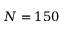<formula> <loc_0><loc_0><loc_500><loc_500>N = 1 5 0</formula> 